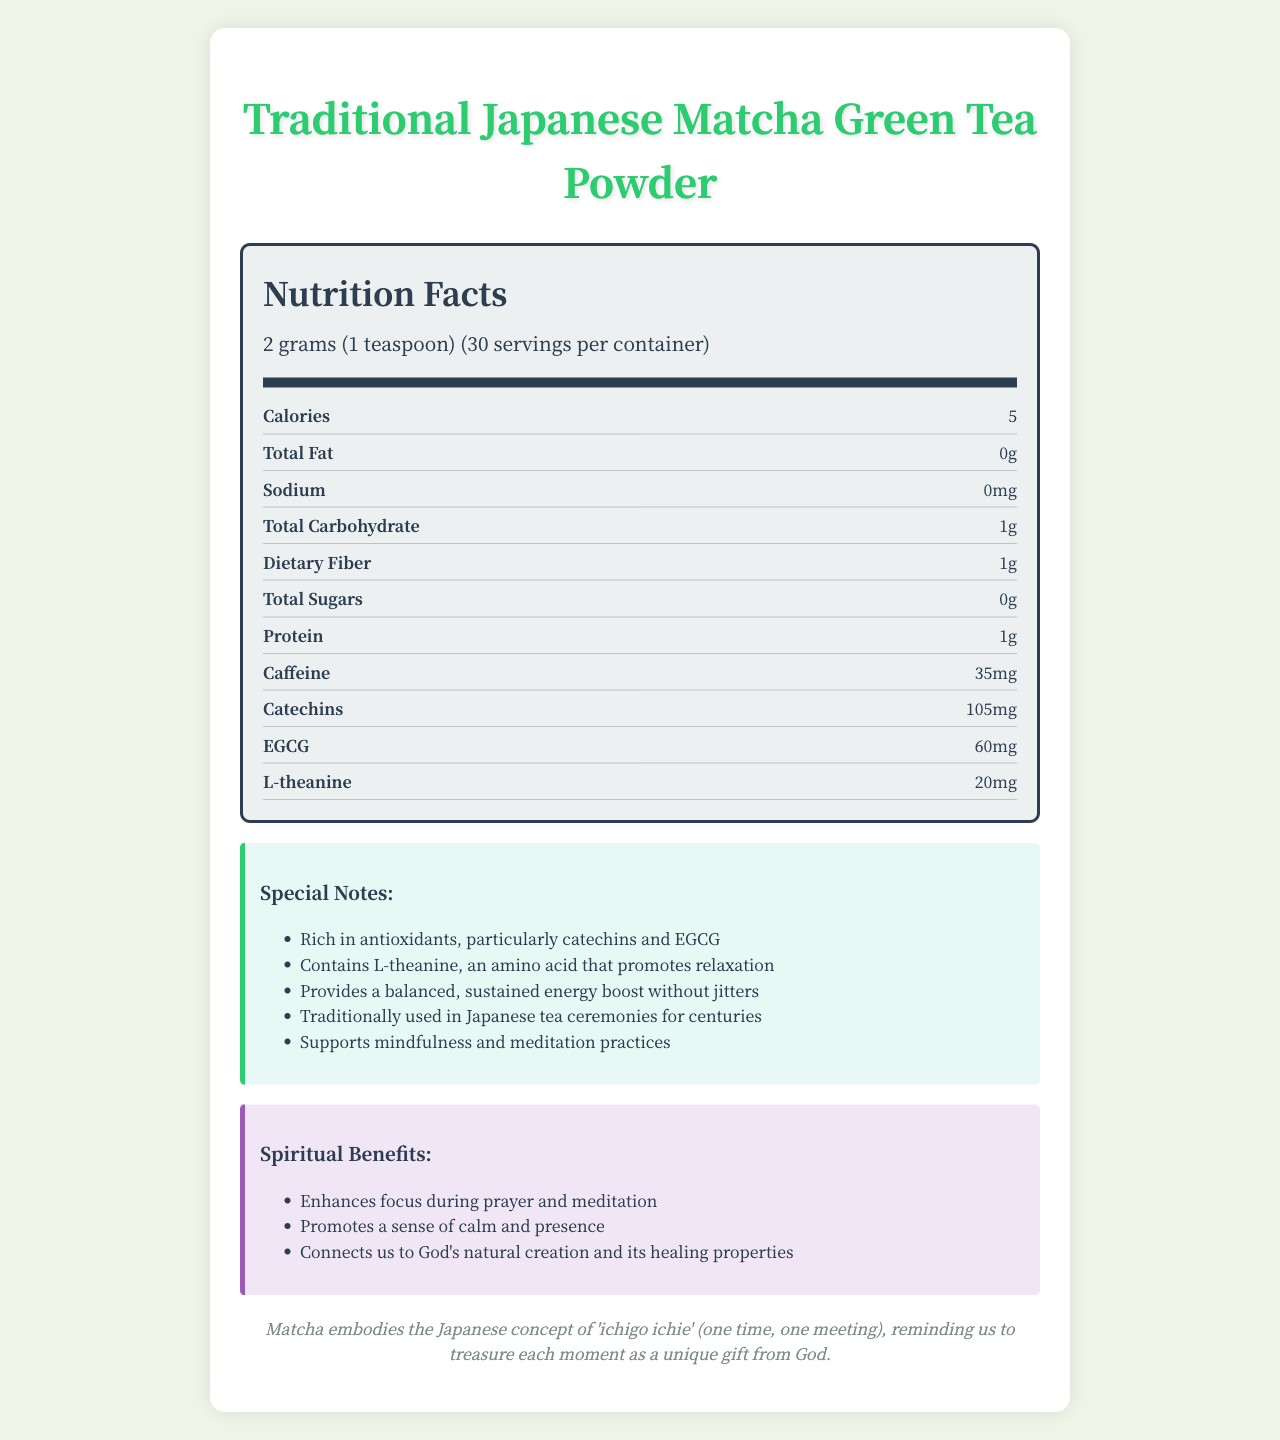what is the serving size? The document specifies the serving size as 2 grams (1 teaspoon).
Answer: 2 grams (1 teaspoon) how many servings are in each container? The document states there are 30 servings per container.
Answer: 30 servings how many calories are in one serving? One serving of the matcha green tea powder contains 5 calories according to the Nutrition Facts.
Answer: 5 calories how much caffeine is in one serving? The Nutrition Facts section indicates that one serving contains 35mg of caffeine.
Answer: 35mg what is the amount of dietary fiber per serving? The document lists 1g of dietary fiber per serving.
Answer: 1g which nutrient is present in the highest quantity? A. Caffeine B. L-theanine C. Catechins D. EGCG The document mentions that catechins are present in the amount of 105mg, which is the highest among the listed nutrients.
Answer: C. Catechins what special note is mentioned about L-theanine? A. Promotes relaxation B. Enhances energy C. Prevents inflammation One of the special notes indicates that L-theanine is an amino acid that promotes relaxation.
Answer: A. Promotes relaxation does the label indicate that the product contains any allergens? The allergen information notes that the product is processed in a facility that also handles soy and tree nuts.
Answer: Yes summarize the spiritual benefits of the matcha green tea powder The spiritual benefits section highlights that the tea enhances focus during prayer and meditation, promotes a sense of calm and presence, and connects us to God's creation and its healing properties.
Answer: Enhances focus during prayer and meditation, promotes a sense of calm and presence, and connects us to God's natural creation and its healing properties how can matcha green tea powder enhance spiritual practices? The spiritual benefits note that the tea enhances focus during prayer and meditation, promotes a sense of calm, and connects us to the natural creation's healing properties.
Answer: Enhances focus, promotes calm, connects to nature describe the preparation method for the matcha green tea powder The document suggests whisking 1 teaspoon (2g) with 2 ounces of hot water at 175°F until frothy, and then adding more water or milk if desired.
Answer: Whisk 1 teaspoon (2g) with 2 ounces of hot water (175°F) until frothy, then add more water or milk to taste why might matcha be significant in Japanese culture? The cultural significance section states that matcha embodies the Japanese concept of 'ichigo ichie', which is about treasuring each moment as a unique gift.
Answer: Represents 'ichigo ichie', treasuring each moment how does matcha provide energy without causing jitters? The special notes mention that matcha provides a balanced, sustained energy boost without jitters due to its L-theanine content.
Answer: Contains L-theanine and caffeine for balanced energy what percentage of daily value (DV) of Vitamin C does one serving provide? The Nutrition Facts indicate that one serving of matcha green tea powder provides 2% of the daily value of Vitamin C.
Answer: 2% DV which of the following nutrients are present in matcha green tea powder? A. Vitamin D B. Potassium C. Riboflavin D. Magnesium The nutrient information lists potassium as one of the nutrients present in the matcha green tea powder with 1% DV.
Answer: B. Potassium how long has matcha been used in Japanese tea ceremonies? One of the special notes indicates that matcha has been traditionally used in Japanese tea ceremonies for centuries.
Answer: Centuries is there any information about polyphenol content in the matcha green tea powder? The document does not mention polyphenol specifically among its nutrient details.
Answer: Not enough information what is emphasized about the Japanese concept 'ichigo ichie' in relation to matcha? The cultural significance section describes that matcha embodies the concept of 'ichigo ichie', emphasizing treasuring each moment as a unique gift from God.
Answer: Treasuring each moment as a unique gift from God 